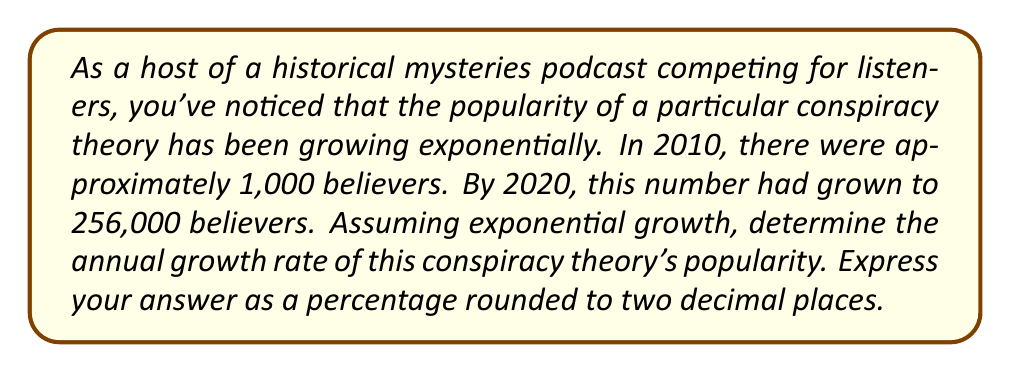Can you solve this math problem? To solve this problem, we'll use the exponential growth formula:

$$A = P(1 + r)^t$$

Where:
$A$ = Final amount (256,000 believers)
$P$ = Initial amount (1,000 believers)
$r$ = Annual growth rate (what we're solving for)
$t$ = Time period (10 years)

Let's substitute the known values:

$$256,000 = 1,000(1 + r)^{10}$$

Now, we'll solve for $r$:

1) Divide both sides by 1,000:
   $$256 = (1 + r)^{10}$$

2) Take the 10th root of both sides:
   $$\sqrt[10]{256} = 1 + r$$

3) Simplify the left side:
   $$2^{\frac{8}{10}} = 1 + r$$
   $$2^{0.8} = 1 + r$$

4) Calculate $2^{0.8}$:
   $$1.7411 = 1 + r$$

5) Subtract 1 from both sides:
   $$0.7411 = r$$

6) Convert to a percentage:
   $$r = 0.7411 \times 100\% = 74.11\%$$

Rounding to two decimal places, we get 74.11%.
Answer: 74.11% 